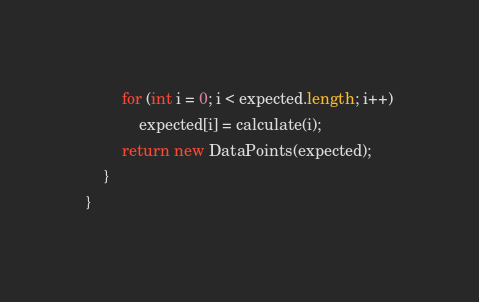<code> <loc_0><loc_0><loc_500><loc_500><_Java_>		for (int i = 0; i < expected.length; i++)
			expected[i] = calculate(i);
		return new DataPoints(expected);
	}
}
</code> 